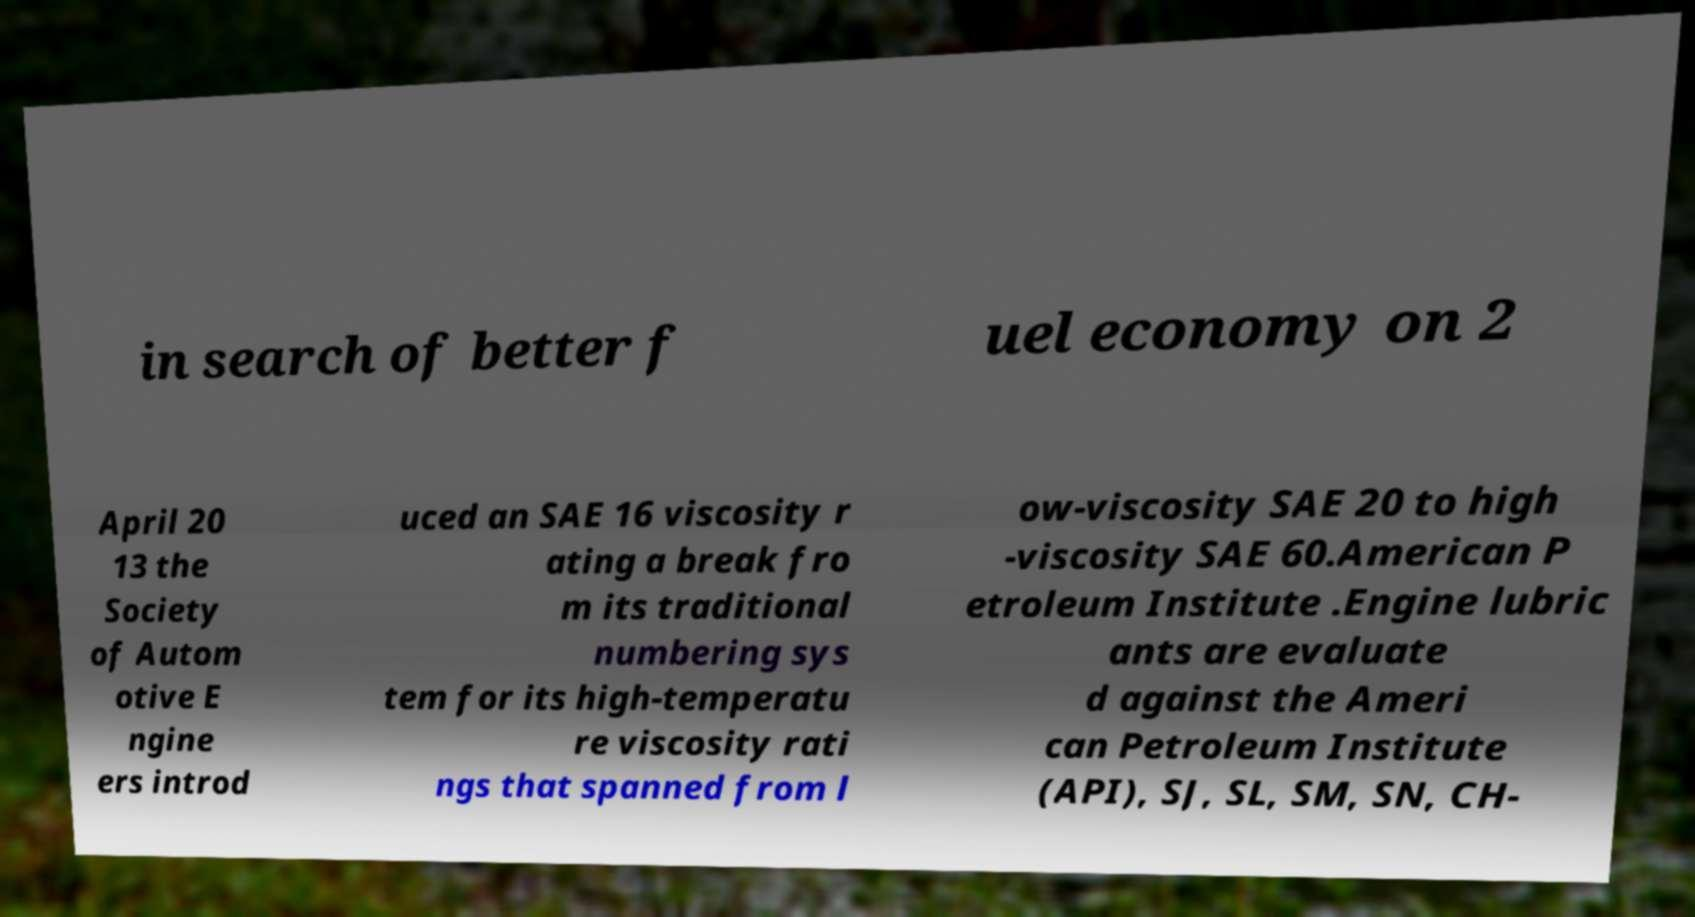Could you assist in decoding the text presented in this image and type it out clearly? in search of better f uel economy on 2 April 20 13 the Society of Autom otive E ngine ers introd uced an SAE 16 viscosity r ating a break fro m its traditional numbering sys tem for its high-temperatu re viscosity rati ngs that spanned from l ow-viscosity SAE 20 to high -viscosity SAE 60.American P etroleum Institute .Engine lubric ants are evaluate d against the Ameri can Petroleum Institute (API), SJ, SL, SM, SN, CH- 